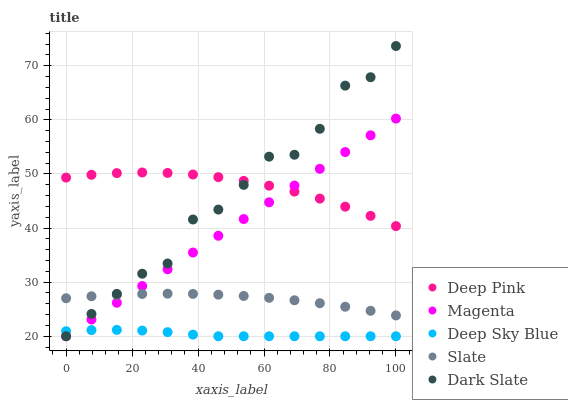Does Deep Sky Blue have the minimum area under the curve?
Answer yes or no. Yes. Does Deep Pink have the maximum area under the curve?
Answer yes or no. Yes. Does Magenta have the minimum area under the curve?
Answer yes or no. No. Does Magenta have the maximum area under the curve?
Answer yes or no. No. Is Magenta the smoothest?
Answer yes or no. Yes. Is Dark Slate the roughest?
Answer yes or no. Yes. Is Deep Pink the smoothest?
Answer yes or no. No. Is Deep Pink the roughest?
Answer yes or no. No. Does Dark Slate have the lowest value?
Answer yes or no. Yes. Does Deep Pink have the lowest value?
Answer yes or no. No. Does Dark Slate have the highest value?
Answer yes or no. Yes. Does Magenta have the highest value?
Answer yes or no. No. Is Deep Sky Blue less than Slate?
Answer yes or no. Yes. Is Deep Pink greater than Slate?
Answer yes or no. Yes. Does Deep Pink intersect Dark Slate?
Answer yes or no. Yes. Is Deep Pink less than Dark Slate?
Answer yes or no. No. Is Deep Pink greater than Dark Slate?
Answer yes or no. No. Does Deep Sky Blue intersect Slate?
Answer yes or no. No. 